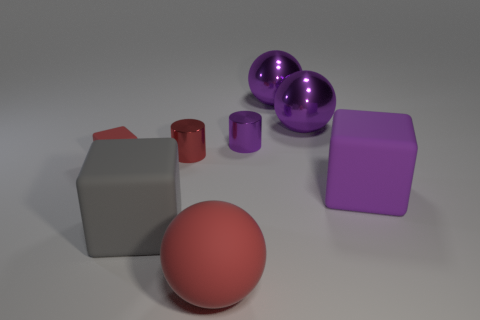The small red rubber object has what shape?
Ensure brevity in your answer.  Cube. What number of tiny metal cylinders are the same color as the rubber sphere?
Give a very brief answer. 1. There is a block that is the same color as the big rubber ball; what is its material?
Keep it short and to the point. Rubber. Are there any other things made of the same material as the tiny purple object?
Provide a succinct answer. Yes. There is another cylinder that is the same size as the red metallic cylinder; what is it made of?
Your answer should be compact. Metal. Is the color of the sphere that is in front of the small block the same as the small object left of the large gray cube?
Your response must be concise. Yes. Are there any red rubber things that are on the left side of the big ball in front of the small red block?
Your answer should be compact. Yes. Do the small thing right of the red cylinder and the metallic object in front of the small purple thing have the same shape?
Ensure brevity in your answer.  Yes. Is the material of the cylinder on the right side of the small red shiny cylinder the same as the block right of the large red object?
Offer a very short reply. No. The big block that is to the left of the big purple thing that is in front of the tiny rubber cube is made of what material?
Offer a terse response. Rubber. 